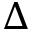<formula> <loc_0><loc_0><loc_500><loc_500>\Delta</formula> 